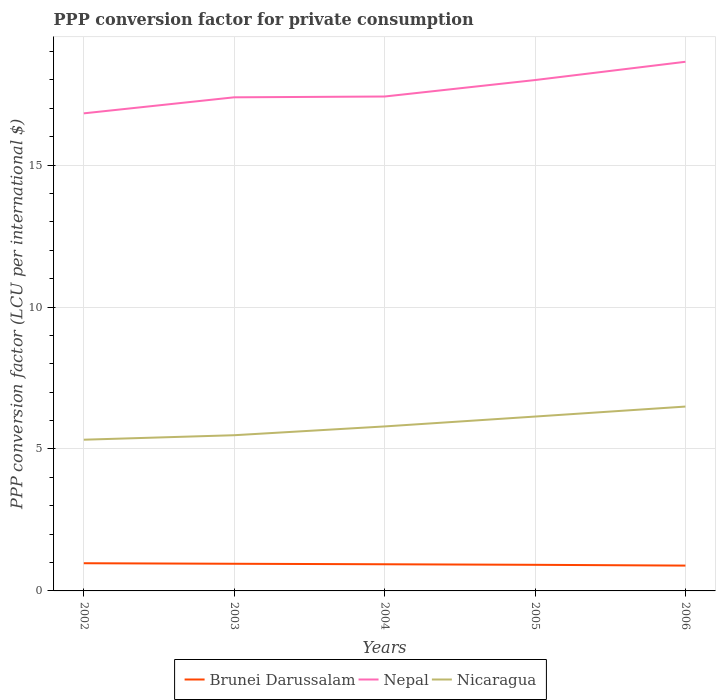How many different coloured lines are there?
Your response must be concise. 3. Is the number of lines equal to the number of legend labels?
Your answer should be compact. Yes. Across all years, what is the maximum PPP conversion factor for private consumption in Nicaragua?
Provide a short and direct response. 5.33. In which year was the PPP conversion factor for private consumption in Brunei Darussalam maximum?
Keep it short and to the point. 2006. What is the total PPP conversion factor for private consumption in Brunei Darussalam in the graph?
Give a very brief answer. 0.03. What is the difference between the highest and the second highest PPP conversion factor for private consumption in Nicaragua?
Make the answer very short. 1.17. What is the difference between the highest and the lowest PPP conversion factor for private consumption in Nicaragua?
Ensure brevity in your answer.  2. Is the PPP conversion factor for private consumption in Nicaragua strictly greater than the PPP conversion factor for private consumption in Brunei Darussalam over the years?
Your answer should be very brief. No. How many lines are there?
Your answer should be compact. 3. Does the graph contain any zero values?
Provide a succinct answer. No. Does the graph contain grids?
Give a very brief answer. Yes. How many legend labels are there?
Your answer should be very brief. 3. How are the legend labels stacked?
Keep it short and to the point. Horizontal. What is the title of the graph?
Provide a succinct answer. PPP conversion factor for private consumption. What is the label or title of the X-axis?
Ensure brevity in your answer.  Years. What is the label or title of the Y-axis?
Provide a short and direct response. PPP conversion factor (LCU per international $). What is the PPP conversion factor (LCU per international $) in Brunei Darussalam in 2002?
Your answer should be very brief. 0.98. What is the PPP conversion factor (LCU per international $) of Nepal in 2002?
Ensure brevity in your answer.  16.82. What is the PPP conversion factor (LCU per international $) of Nicaragua in 2002?
Make the answer very short. 5.33. What is the PPP conversion factor (LCU per international $) of Brunei Darussalam in 2003?
Your answer should be compact. 0.96. What is the PPP conversion factor (LCU per international $) in Nepal in 2003?
Your response must be concise. 17.39. What is the PPP conversion factor (LCU per international $) in Nicaragua in 2003?
Offer a terse response. 5.49. What is the PPP conversion factor (LCU per international $) in Brunei Darussalam in 2004?
Keep it short and to the point. 0.94. What is the PPP conversion factor (LCU per international $) in Nepal in 2004?
Provide a succinct answer. 17.42. What is the PPP conversion factor (LCU per international $) in Nicaragua in 2004?
Your answer should be compact. 5.8. What is the PPP conversion factor (LCU per international $) in Brunei Darussalam in 2005?
Keep it short and to the point. 0.92. What is the PPP conversion factor (LCU per international $) of Nepal in 2005?
Offer a very short reply. 18. What is the PPP conversion factor (LCU per international $) in Nicaragua in 2005?
Your response must be concise. 6.14. What is the PPP conversion factor (LCU per international $) in Brunei Darussalam in 2006?
Your answer should be compact. 0.89. What is the PPP conversion factor (LCU per international $) of Nepal in 2006?
Offer a very short reply. 18.64. What is the PPP conversion factor (LCU per international $) in Nicaragua in 2006?
Ensure brevity in your answer.  6.49. Across all years, what is the maximum PPP conversion factor (LCU per international $) of Brunei Darussalam?
Your answer should be compact. 0.98. Across all years, what is the maximum PPP conversion factor (LCU per international $) of Nepal?
Your response must be concise. 18.64. Across all years, what is the maximum PPP conversion factor (LCU per international $) of Nicaragua?
Offer a terse response. 6.49. Across all years, what is the minimum PPP conversion factor (LCU per international $) in Brunei Darussalam?
Provide a short and direct response. 0.89. Across all years, what is the minimum PPP conversion factor (LCU per international $) in Nepal?
Make the answer very short. 16.82. Across all years, what is the minimum PPP conversion factor (LCU per international $) in Nicaragua?
Give a very brief answer. 5.33. What is the total PPP conversion factor (LCU per international $) in Brunei Darussalam in the graph?
Offer a terse response. 4.68. What is the total PPP conversion factor (LCU per international $) of Nepal in the graph?
Make the answer very short. 88.27. What is the total PPP conversion factor (LCU per international $) of Nicaragua in the graph?
Provide a succinct answer. 29.25. What is the difference between the PPP conversion factor (LCU per international $) of Brunei Darussalam in 2002 and that in 2003?
Keep it short and to the point. 0.02. What is the difference between the PPP conversion factor (LCU per international $) in Nepal in 2002 and that in 2003?
Ensure brevity in your answer.  -0.57. What is the difference between the PPP conversion factor (LCU per international $) in Nicaragua in 2002 and that in 2003?
Keep it short and to the point. -0.16. What is the difference between the PPP conversion factor (LCU per international $) in Brunei Darussalam in 2002 and that in 2004?
Make the answer very short. 0.04. What is the difference between the PPP conversion factor (LCU per international $) in Nepal in 2002 and that in 2004?
Make the answer very short. -0.59. What is the difference between the PPP conversion factor (LCU per international $) of Nicaragua in 2002 and that in 2004?
Ensure brevity in your answer.  -0.47. What is the difference between the PPP conversion factor (LCU per international $) of Brunei Darussalam in 2002 and that in 2005?
Keep it short and to the point. 0.06. What is the difference between the PPP conversion factor (LCU per international $) of Nepal in 2002 and that in 2005?
Ensure brevity in your answer.  -1.17. What is the difference between the PPP conversion factor (LCU per international $) of Nicaragua in 2002 and that in 2005?
Keep it short and to the point. -0.82. What is the difference between the PPP conversion factor (LCU per international $) of Brunei Darussalam in 2002 and that in 2006?
Make the answer very short. 0.08. What is the difference between the PPP conversion factor (LCU per international $) of Nepal in 2002 and that in 2006?
Offer a very short reply. -1.82. What is the difference between the PPP conversion factor (LCU per international $) in Nicaragua in 2002 and that in 2006?
Your answer should be compact. -1.17. What is the difference between the PPP conversion factor (LCU per international $) in Brunei Darussalam in 2003 and that in 2004?
Provide a short and direct response. 0.02. What is the difference between the PPP conversion factor (LCU per international $) in Nepal in 2003 and that in 2004?
Provide a short and direct response. -0.03. What is the difference between the PPP conversion factor (LCU per international $) in Nicaragua in 2003 and that in 2004?
Give a very brief answer. -0.31. What is the difference between the PPP conversion factor (LCU per international $) in Brunei Darussalam in 2003 and that in 2005?
Offer a very short reply. 0.04. What is the difference between the PPP conversion factor (LCU per international $) of Nepal in 2003 and that in 2005?
Give a very brief answer. -0.61. What is the difference between the PPP conversion factor (LCU per international $) of Nicaragua in 2003 and that in 2005?
Give a very brief answer. -0.66. What is the difference between the PPP conversion factor (LCU per international $) in Brunei Darussalam in 2003 and that in 2006?
Keep it short and to the point. 0.06. What is the difference between the PPP conversion factor (LCU per international $) of Nepal in 2003 and that in 2006?
Your answer should be compact. -1.25. What is the difference between the PPP conversion factor (LCU per international $) in Nicaragua in 2003 and that in 2006?
Give a very brief answer. -1.01. What is the difference between the PPP conversion factor (LCU per international $) in Brunei Darussalam in 2004 and that in 2005?
Offer a terse response. 0.02. What is the difference between the PPP conversion factor (LCU per international $) in Nepal in 2004 and that in 2005?
Your answer should be very brief. -0.58. What is the difference between the PPP conversion factor (LCU per international $) of Nicaragua in 2004 and that in 2005?
Your answer should be very brief. -0.35. What is the difference between the PPP conversion factor (LCU per international $) of Brunei Darussalam in 2004 and that in 2006?
Your answer should be very brief. 0.05. What is the difference between the PPP conversion factor (LCU per international $) of Nepal in 2004 and that in 2006?
Keep it short and to the point. -1.22. What is the difference between the PPP conversion factor (LCU per international $) in Nicaragua in 2004 and that in 2006?
Give a very brief answer. -0.7. What is the difference between the PPP conversion factor (LCU per international $) in Brunei Darussalam in 2005 and that in 2006?
Provide a succinct answer. 0.03. What is the difference between the PPP conversion factor (LCU per international $) of Nepal in 2005 and that in 2006?
Ensure brevity in your answer.  -0.64. What is the difference between the PPP conversion factor (LCU per international $) in Nicaragua in 2005 and that in 2006?
Make the answer very short. -0.35. What is the difference between the PPP conversion factor (LCU per international $) in Brunei Darussalam in 2002 and the PPP conversion factor (LCU per international $) in Nepal in 2003?
Give a very brief answer. -16.41. What is the difference between the PPP conversion factor (LCU per international $) in Brunei Darussalam in 2002 and the PPP conversion factor (LCU per international $) in Nicaragua in 2003?
Make the answer very short. -4.51. What is the difference between the PPP conversion factor (LCU per international $) of Nepal in 2002 and the PPP conversion factor (LCU per international $) of Nicaragua in 2003?
Offer a terse response. 11.34. What is the difference between the PPP conversion factor (LCU per international $) in Brunei Darussalam in 2002 and the PPP conversion factor (LCU per international $) in Nepal in 2004?
Offer a terse response. -16.44. What is the difference between the PPP conversion factor (LCU per international $) in Brunei Darussalam in 2002 and the PPP conversion factor (LCU per international $) in Nicaragua in 2004?
Your answer should be compact. -4.82. What is the difference between the PPP conversion factor (LCU per international $) of Nepal in 2002 and the PPP conversion factor (LCU per international $) of Nicaragua in 2004?
Make the answer very short. 11.03. What is the difference between the PPP conversion factor (LCU per international $) of Brunei Darussalam in 2002 and the PPP conversion factor (LCU per international $) of Nepal in 2005?
Provide a succinct answer. -17.02. What is the difference between the PPP conversion factor (LCU per international $) in Brunei Darussalam in 2002 and the PPP conversion factor (LCU per international $) in Nicaragua in 2005?
Provide a short and direct response. -5.17. What is the difference between the PPP conversion factor (LCU per international $) in Nepal in 2002 and the PPP conversion factor (LCU per international $) in Nicaragua in 2005?
Provide a short and direct response. 10.68. What is the difference between the PPP conversion factor (LCU per international $) in Brunei Darussalam in 2002 and the PPP conversion factor (LCU per international $) in Nepal in 2006?
Your answer should be compact. -17.67. What is the difference between the PPP conversion factor (LCU per international $) in Brunei Darussalam in 2002 and the PPP conversion factor (LCU per international $) in Nicaragua in 2006?
Your answer should be very brief. -5.52. What is the difference between the PPP conversion factor (LCU per international $) in Nepal in 2002 and the PPP conversion factor (LCU per international $) in Nicaragua in 2006?
Your answer should be very brief. 10.33. What is the difference between the PPP conversion factor (LCU per international $) of Brunei Darussalam in 2003 and the PPP conversion factor (LCU per international $) of Nepal in 2004?
Make the answer very short. -16.46. What is the difference between the PPP conversion factor (LCU per international $) in Brunei Darussalam in 2003 and the PPP conversion factor (LCU per international $) in Nicaragua in 2004?
Provide a succinct answer. -4.84. What is the difference between the PPP conversion factor (LCU per international $) in Nepal in 2003 and the PPP conversion factor (LCU per international $) in Nicaragua in 2004?
Keep it short and to the point. 11.6. What is the difference between the PPP conversion factor (LCU per international $) of Brunei Darussalam in 2003 and the PPP conversion factor (LCU per international $) of Nepal in 2005?
Offer a terse response. -17.04. What is the difference between the PPP conversion factor (LCU per international $) in Brunei Darussalam in 2003 and the PPP conversion factor (LCU per international $) in Nicaragua in 2005?
Offer a very short reply. -5.19. What is the difference between the PPP conversion factor (LCU per international $) of Nepal in 2003 and the PPP conversion factor (LCU per international $) of Nicaragua in 2005?
Your answer should be compact. 11.25. What is the difference between the PPP conversion factor (LCU per international $) of Brunei Darussalam in 2003 and the PPP conversion factor (LCU per international $) of Nepal in 2006?
Provide a short and direct response. -17.69. What is the difference between the PPP conversion factor (LCU per international $) of Brunei Darussalam in 2003 and the PPP conversion factor (LCU per international $) of Nicaragua in 2006?
Your answer should be compact. -5.54. What is the difference between the PPP conversion factor (LCU per international $) in Nepal in 2003 and the PPP conversion factor (LCU per international $) in Nicaragua in 2006?
Ensure brevity in your answer.  10.9. What is the difference between the PPP conversion factor (LCU per international $) of Brunei Darussalam in 2004 and the PPP conversion factor (LCU per international $) of Nepal in 2005?
Give a very brief answer. -17.06. What is the difference between the PPP conversion factor (LCU per international $) in Brunei Darussalam in 2004 and the PPP conversion factor (LCU per international $) in Nicaragua in 2005?
Give a very brief answer. -5.2. What is the difference between the PPP conversion factor (LCU per international $) in Nepal in 2004 and the PPP conversion factor (LCU per international $) in Nicaragua in 2005?
Provide a succinct answer. 11.28. What is the difference between the PPP conversion factor (LCU per international $) of Brunei Darussalam in 2004 and the PPP conversion factor (LCU per international $) of Nepal in 2006?
Your answer should be compact. -17.7. What is the difference between the PPP conversion factor (LCU per international $) of Brunei Darussalam in 2004 and the PPP conversion factor (LCU per international $) of Nicaragua in 2006?
Offer a terse response. -5.56. What is the difference between the PPP conversion factor (LCU per international $) in Nepal in 2004 and the PPP conversion factor (LCU per international $) in Nicaragua in 2006?
Your answer should be very brief. 10.92. What is the difference between the PPP conversion factor (LCU per international $) in Brunei Darussalam in 2005 and the PPP conversion factor (LCU per international $) in Nepal in 2006?
Ensure brevity in your answer.  -17.72. What is the difference between the PPP conversion factor (LCU per international $) of Brunei Darussalam in 2005 and the PPP conversion factor (LCU per international $) of Nicaragua in 2006?
Give a very brief answer. -5.58. What is the difference between the PPP conversion factor (LCU per international $) of Nepal in 2005 and the PPP conversion factor (LCU per international $) of Nicaragua in 2006?
Your answer should be compact. 11.5. What is the average PPP conversion factor (LCU per international $) in Brunei Darussalam per year?
Make the answer very short. 0.94. What is the average PPP conversion factor (LCU per international $) of Nepal per year?
Your answer should be very brief. 17.65. What is the average PPP conversion factor (LCU per international $) of Nicaragua per year?
Your response must be concise. 5.85. In the year 2002, what is the difference between the PPP conversion factor (LCU per international $) in Brunei Darussalam and PPP conversion factor (LCU per international $) in Nepal?
Offer a very short reply. -15.85. In the year 2002, what is the difference between the PPP conversion factor (LCU per international $) in Brunei Darussalam and PPP conversion factor (LCU per international $) in Nicaragua?
Provide a short and direct response. -4.35. In the year 2002, what is the difference between the PPP conversion factor (LCU per international $) in Nepal and PPP conversion factor (LCU per international $) in Nicaragua?
Your answer should be very brief. 11.5. In the year 2003, what is the difference between the PPP conversion factor (LCU per international $) in Brunei Darussalam and PPP conversion factor (LCU per international $) in Nepal?
Offer a very short reply. -16.43. In the year 2003, what is the difference between the PPP conversion factor (LCU per international $) in Brunei Darussalam and PPP conversion factor (LCU per international $) in Nicaragua?
Provide a succinct answer. -4.53. In the year 2003, what is the difference between the PPP conversion factor (LCU per international $) in Nepal and PPP conversion factor (LCU per international $) in Nicaragua?
Make the answer very short. 11.9. In the year 2004, what is the difference between the PPP conversion factor (LCU per international $) of Brunei Darussalam and PPP conversion factor (LCU per international $) of Nepal?
Give a very brief answer. -16.48. In the year 2004, what is the difference between the PPP conversion factor (LCU per international $) in Brunei Darussalam and PPP conversion factor (LCU per international $) in Nicaragua?
Provide a short and direct response. -4.86. In the year 2004, what is the difference between the PPP conversion factor (LCU per international $) in Nepal and PPP conversion factor (LCU per international $) in Nicaragua?
Provide a short and direct response. 11.62. In the year 2005, what is the difference between the PPP conversion factor (LCU per international $) of Brunei Darussalam and PPP conversion factor (LCU per international $) of Nepal?
Give a very brief answer. -17.08. In the year 2005, what is the difference between the PPP conversion factor (LCU per international $) in Brunei Darussalam and PPP conversion factor (LCU per international $) in Nicaragua?
Keep it short and to the point. -5.22. In the year 2005, what is the difference between the PPP conversion factor (LCU per international $) in Nepal and PPP conversion factor (LCU per international $) in Nicaragua?
Offer a very short reply. 11.86. In the year 2006, what is the difference between the PPP conversion factor (LCU per international $) in Brunei Darussalam and PPP conversion factor (LCU per international $) in Nepal?
Your answer should be very brief. -17.75. In the year 2006, what is the difference between the PPP conversion factor (LCU per international $) of Brunei Darussalam and PPP conversion factor (LCU per international $) of Nicaragua?
Your answer should be very brief. -5.6. In the year 2006, what is the difference between the PPP conversion factor (LCU per international $) of Nepal and PPP conversion factor (LCU per international $) of Nicaragua?
Your answer should be very brief. 12.15. What is the ratio of the PPP conversion factor (LCU per international $) in Brunei Darussalam in 2002 to that in 2003?
Offer a terse response. 1.02. What is the ratio of the PPP conversion factor (LCU per international $) in Nepal in 2002 to that in 2003?
Provide a succinct answer. 0.97. What is the ratio of the PPP conversion factor (LCU per international $) of Nicaragua in 2002 to that in 2003?
Provide a succinct answer. 0.97. What is the ratio of the PPP conversion factor (LCU per international $) in Brunei Darussalam in 2002 to that in 2004?
Your answer should be very brief. 1.04. What is the ratio of the PPP conversion factor (LCU per international $) in Nepal in 2002 to that in 2004?
Provide a short and direct response. 0.97. What is the ratio of the PPP conversion factor (LCU per international $) of Nicaragua in 2002 to that in 2004?
Provide a succinct answer. 0.92. What is the ratio of the PPP conversion factor (LCU per international $) of Brunei Darussalam in 2002 to that in 2005?
Ensure brevity in your answer.  1.06. What is the ratio of the PPP conversion factor (LCU per international $) of Nepal in 2002 to that in 2005?
Your answer should be very brief. 0.93. What is the ratio of the PPP conversion factor (LCU per international $) of Nicaragua in 2002 to that in 2005?
Offer a very short reply. 0.87. What is the ratio of the PPP conversion factor (LCU per international $) in Brunei Darussalam in 2002 to that in 2006?
Offer a very short reply. 1.09. What is the ratio of the PPP conversion factor (LCU per international $) of Nepal in 2002 to that in 2006?
Keep it short and to the point. 0.9. What is the ratio of the PPP conversion factor (LCU per international $) of Nicaragua in 2002 to that in 2006?
Your answer should be compact. 0.82. What is the ratio of the PPP conversion factor (LCU per international $) of Brunei Darussalam in 2003 to that in 2004?
Offer a very short reply. 1.02. What is the ratio of the PPP conversion factor (LCU per international $) in Nepal in 2003 to that in 2004?
Provide a succinct answer. 1. What is the ratio of the PPP conversion factor (LCU per international $) in Nicaragua in 2003 to that in 2004?
Provide a succinct answer. 0.95. What is the ratio of the PPP conversion factor (LCU per international $) of Brunei Darussalam in 2003 to that in 2005?
Make the answer very short. 1.04. What is the ratio of the PPP conversion factor (LCU per international $) in Nepal in 2003 to that in 2005?
Offer a very short reply. 0.97. What is the ratio of the PPP conversion factor (LCU per international $) of Nicaragua in 2003 to that in 2005?
Your response must be concise. 0.89. What is the ratio of the PPP conversion factor (LCU per international $) in Brunei Darussalam in 2003 to that in 2006?
Ensure brevity in your answer.  1.07. What is the ratio of the PPP conversion factor (LCU per international $) of Nepal in 2003 to that in 2006?
Make the answer very short. 0.93. What is the ratio of the PPP conversion factor (LCU per international $) of Nicaragua in 2003 to that in 2006?
Provide a succinct answer. 0.84. What is the ratio of the PPP conversion factor (LCU per international $) in Brunei Darussalam in 2004 to that in 2005?
Offer a terse response. 1.02. What is the ratio of the PPP conversion factor (LCU per international $) of Nepal in 2004 to that in 2005?
Keep it short and to the point. 0.97. What is the ratio of the PPP conversion factor (LCU per international $) of Nicaragua in 2004 to that in 2005?
Give a very brief answer. 0.94. What is the ratio of the PPP conversion factor (LCU per international $) of Brunei Darussalam in 2004 to that in 2006?
Give a very brief answer. 1.05. What is the ratio of the PPP conversion factor (LCU per international $) in Nepal in 2004 to that in 2006?
Your answer should be compact. 0.93. What is the ratio of the PPP conversion factor (LCU per international $) of Nicaragua in 2004 to that in 2006?
Offer a very short reply. 0.89. What is the ratio of the PPP conversion factor (LCU per international $) of Brunei Darussalam in 2005 to that in 2006?
Ensure brevity in your answer.  1.03. What is the ratio of the PPP conversion factor (LCU per international $) in Nepal in 2005 to that in 2006?
Offer a very short reply. 0.97. What is the ratio of the PPP conversion factor (LCU per international $) of Nicaragua in 2005 to that in 2006?
Your answer should be compact. 0.95. What is the difference between the highest and the second highest PPP conversion factor (LCU per international $) of Brunei Darussalam?
Provide a short and direct response. 0.02. What is the difference between the highest and the second highest PPP conversion factor (LCU per international $) in Nepal?
Your response must be concise. 0.64. What is the difference between the highest and the second highest PPP conversion factor (LCU per international $) of Nicaragua?
Your answer should be very brief. 0.35. What is the difference between the highest and the lowest PPP conversion factor (LCU per international $) of Brunei Darussalam?
Your answer should be very brief. 0.08. What is the difference between the highest and the lowest PPP conversion factor (LCU per international $) of Nepal?
Keep it short and to the point. 1.82. What is the difference between the highest and the lowest PPP conversion factor (LCU per international $) in Nicaragua?
Provide a succinct answer. 1.17. 